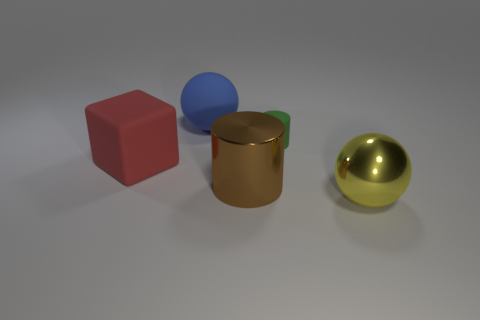What materials might the objects in the image be made from? The objects in the image seem to have surfaces that suggest various materials. The cube looks like it could be made of a matte plastic due to its opaque and even surface. The cylinder and the shiny sphere both have reflective surfaces, which could imply metallic materials; the cylinder might be bronze, and the sphere looks like polished gold. The blue object, due to its transparent and reflective quality, might represent glass or a translucent plastic. 